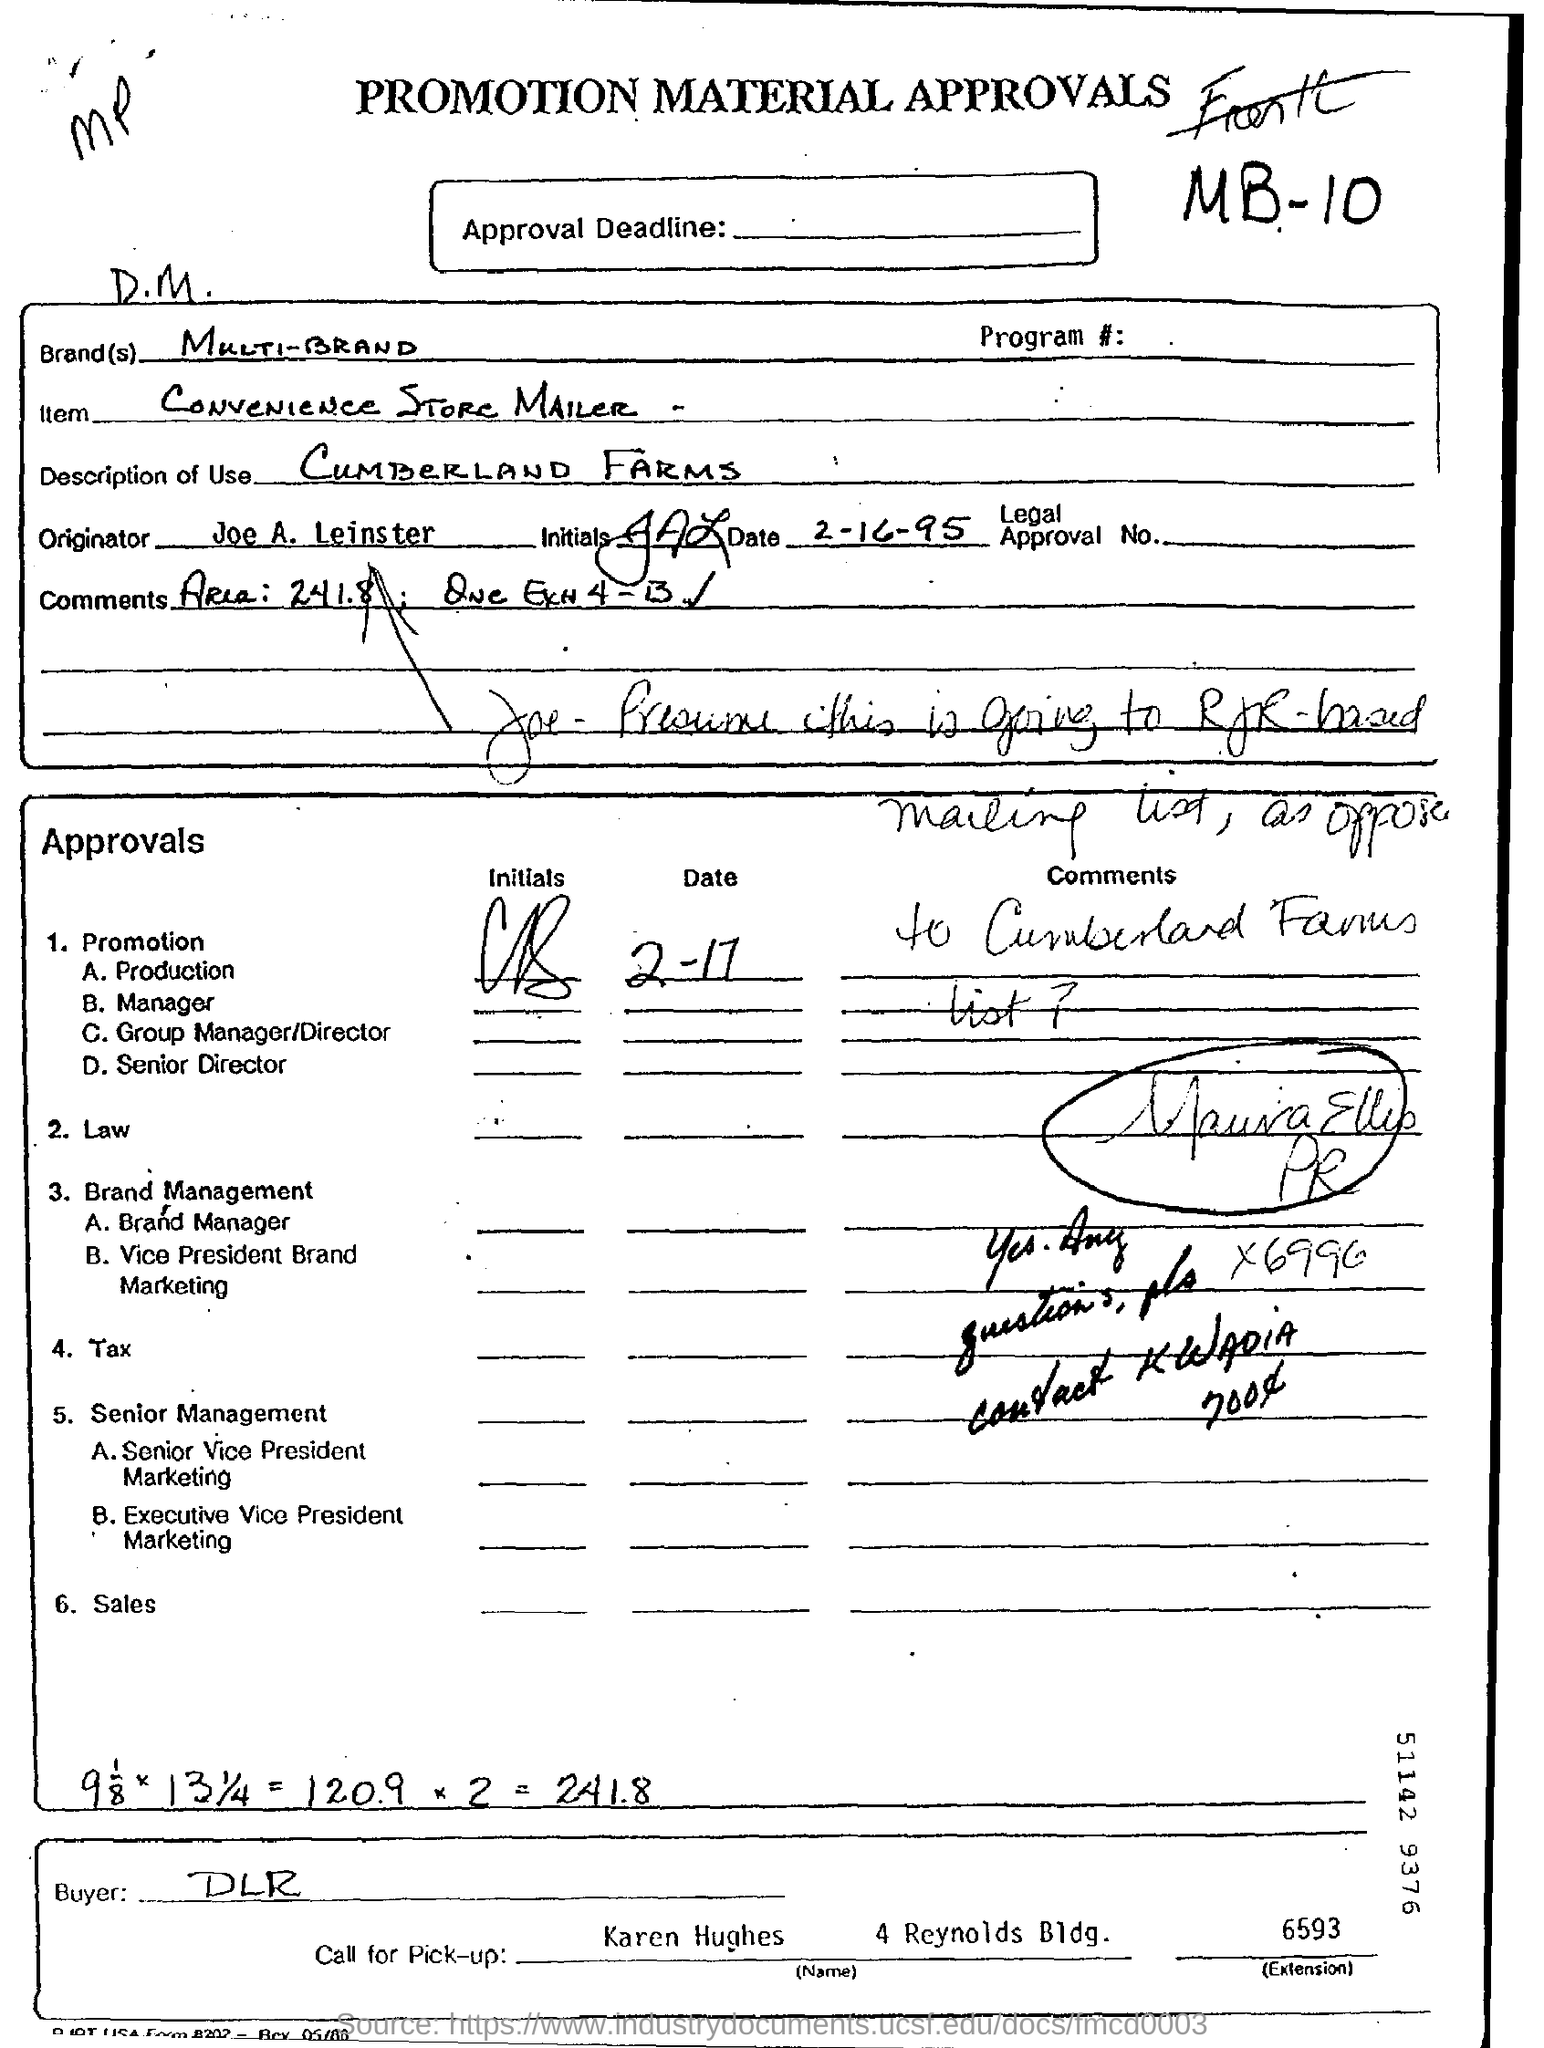What type of document is this?
Make the answer very short. PROMOTION MATERIAL APPROVALS. Which brand's approval is given here?
Provide a short and direct response. MULTI-BRAND. What is the Item mentioned in this document?
Your response must be concise. CONVENIENCE STORE MAILER. 